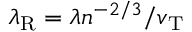Convert formula to latex. <formula><loc_0><loc_0><loc_500><loc_500>\lambda _ { R } = \lambda n ^ { - 2 / 3 } / v _ { T }</formula> 